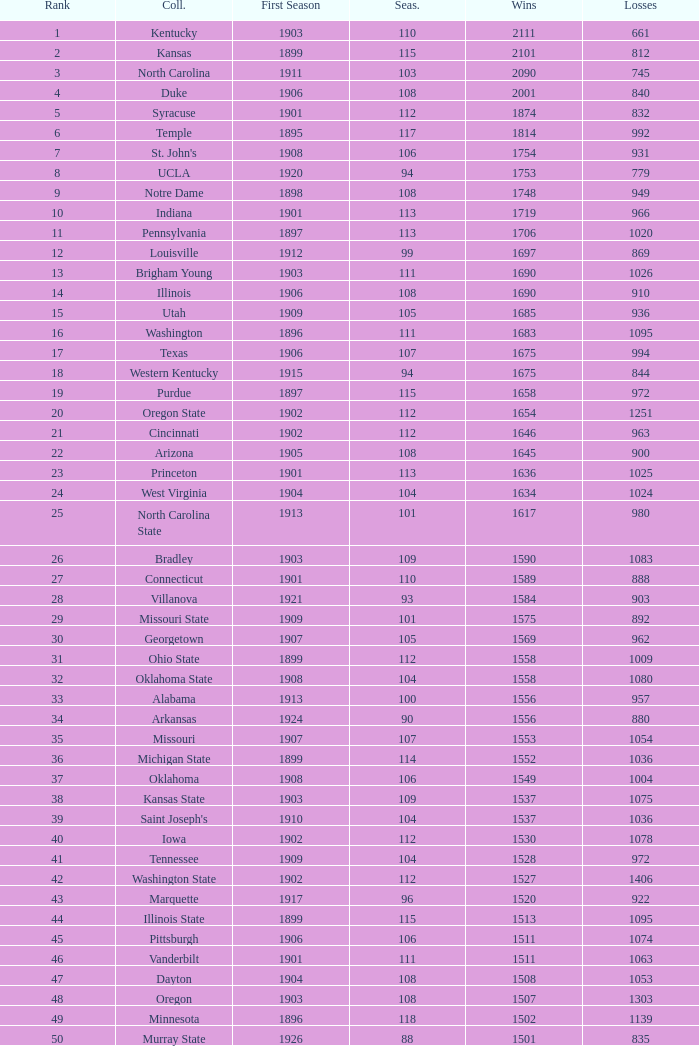How many wins were there for Washington State College with losses greater than 980 and a first season before 1906 and rank greater than 42? 0.0. 